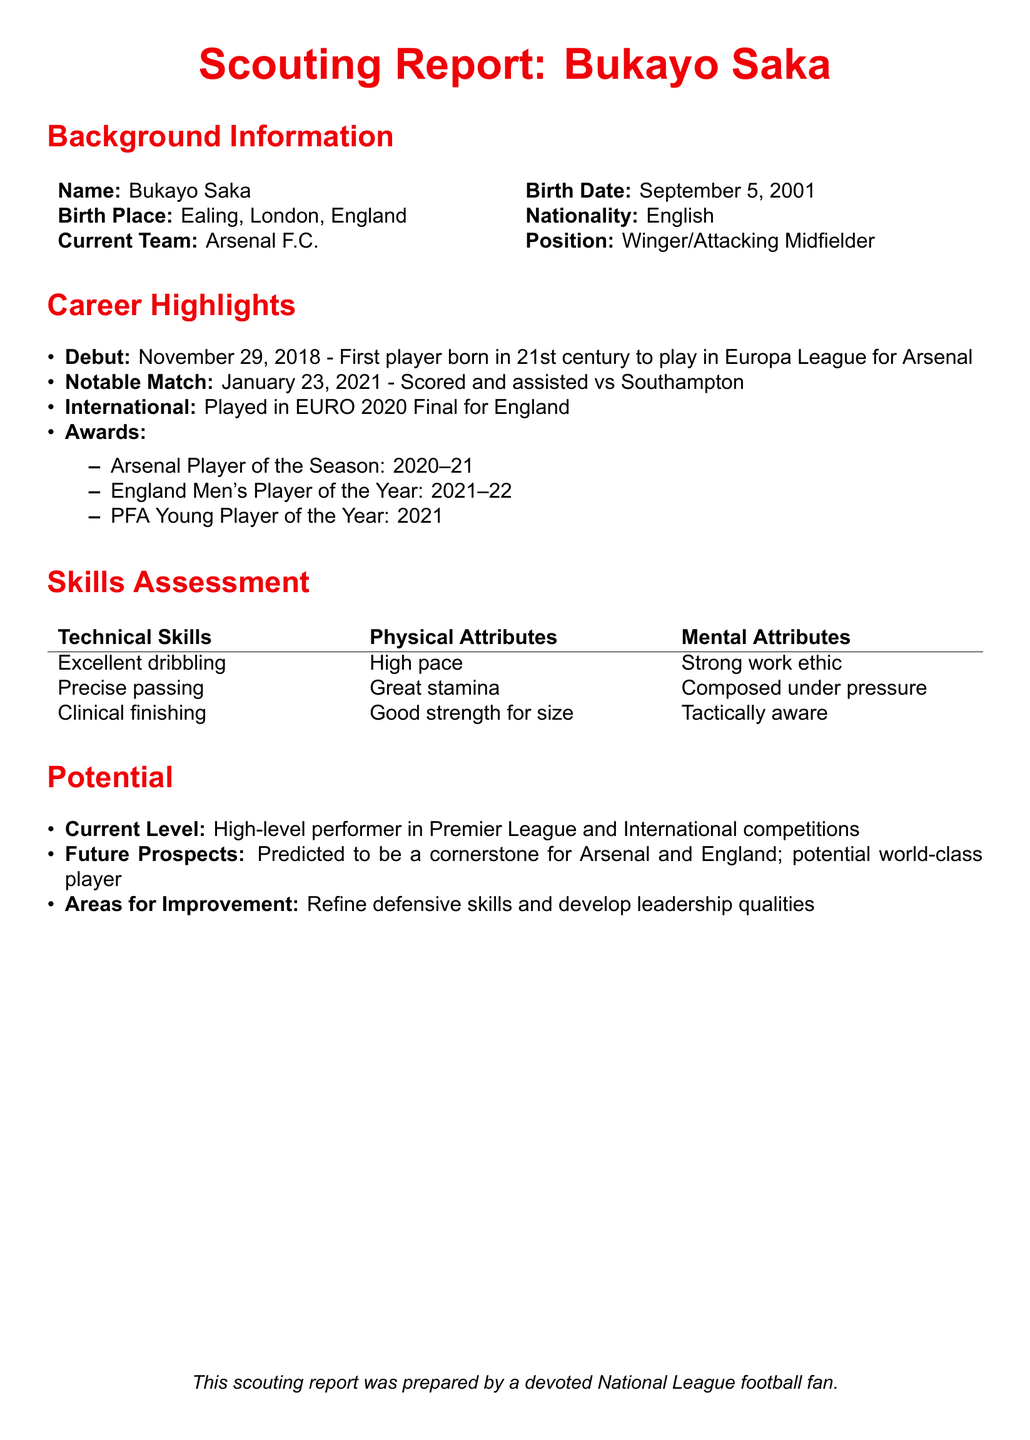What is Bukayo Saka's birth date? Bukayo Saka was born on September 5, 2001, as stated in the background information.
Answer: September 5, 2001 What position does Bukayo Saka play? The document specifies that he plays as a Winger/Attacking Midfielder.
Answer: Winger/Attacking Midfielder What team does Bukayo Saka currently play for? The current team listed for Bukayo Saka is Arsenal F.C.
Answer: Arsenal F.C What award did Bukayo Saka receive in the 2020–21 season? The document states he was awarded Arsenal Player of the Season for 2020–21.
Answer: Arsenal Player of the Season How many total awards are listed in Bukayo Saka's career highlights? Three distinct awards are mentioned under career highlights.
Answer: Three What is Bukayo Saka's current level of play? The document describes him as a high-level performer in Premier League and International competitions.
Answer: High-level performer What is one area for improvement mentioned for Bukayo Saka? The report suggests refining defensive skills as one area for improvement.
Answer: Defensive skills What notable match is referenced in Bukayo Saka's career highlights? The document mentions a match where he scored and assisted against Southampton on January 23, 2021.
Answer: January 23, 2021 What potential is predicted for Bukayo Saka? It is predicted that he could be a cornerstone for Arsenal and England, with potential as a world-class player.
Answer: World-class player 